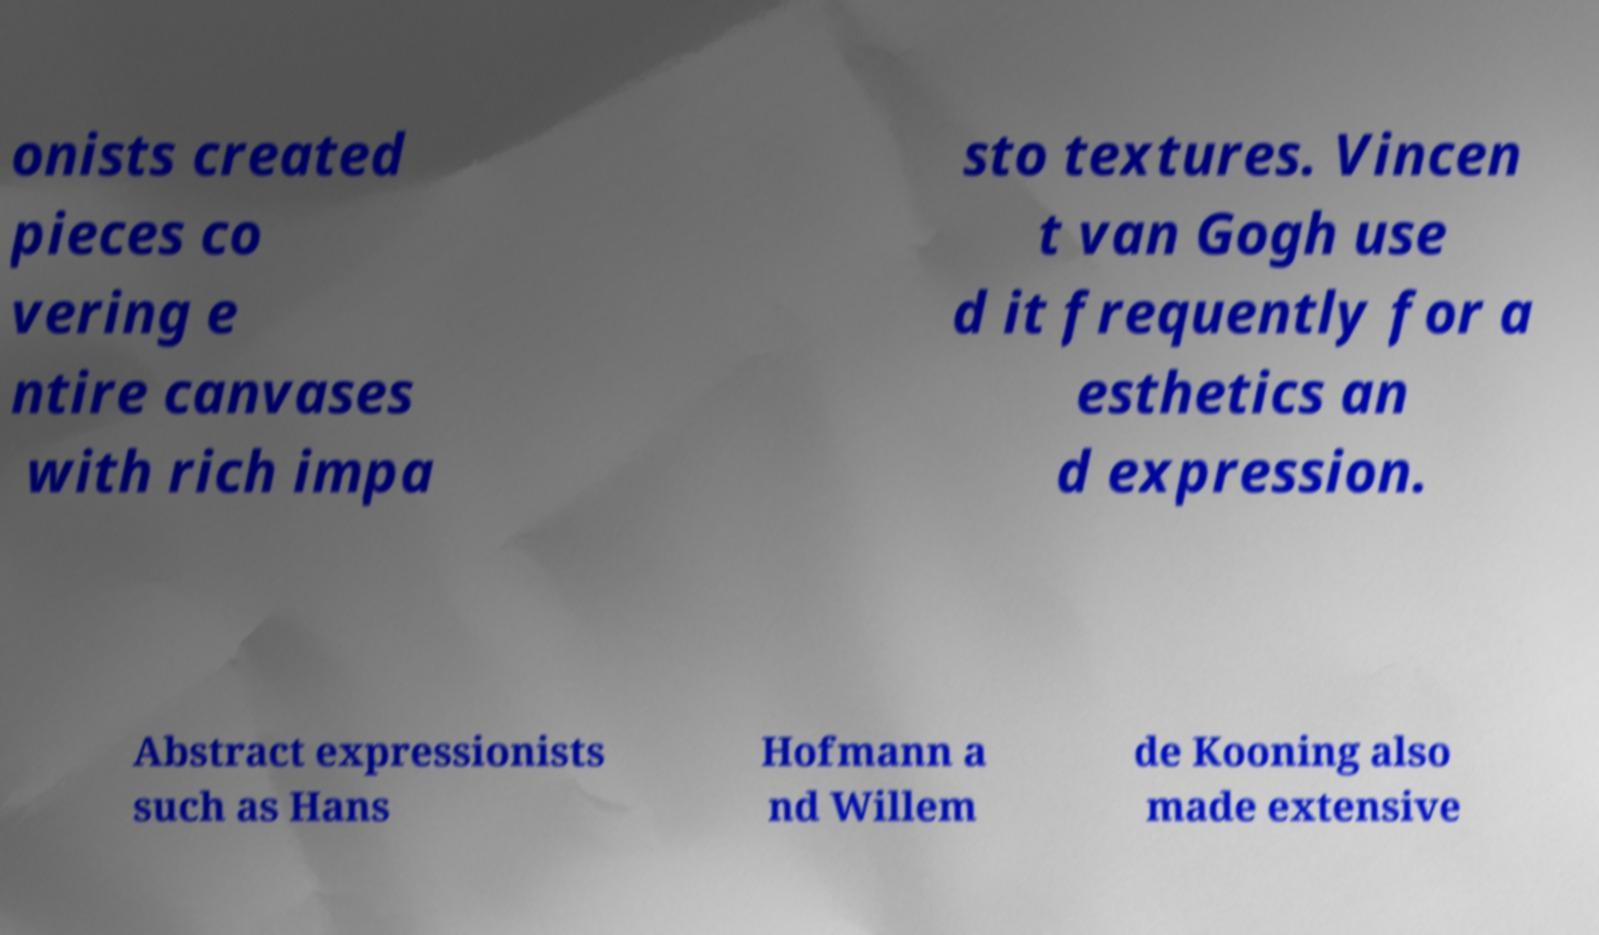Could you extract and type out the text from this image? onists created pieces co vering e ntire canvases with rich impa sto textures. Vincen t van Gogh use d it frequently for a esthetics an d expression. Abstract expressionists such as Hans Hofmann a nd Willem de Kooning also made extensive 